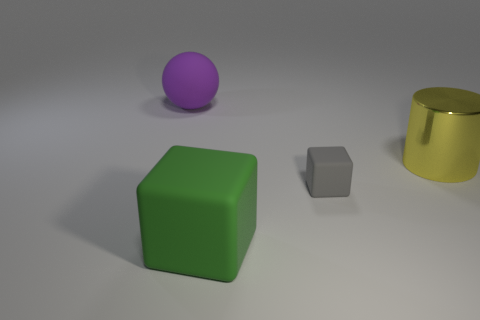Are there fewer gray matte blocks on the right side of the big yellow cylinder than blue rubber blocks?
Make the answer very short. No. Is the material of the large purple sphere the same as the green block?
Provide a succinct answer. Yes. What is the size of the other object that is the same shape as the big green thing?
Provide a short and direct response. Small. What number of things are either matte things behind the cylinder or large matte objects behind the large metal object?
Ensure brevity in your answer.  1. Are there fewer large red rubber things than green matte blocks?
Provide a short and direct response. Yes. Is the size of the purple matte object the same as the rubber cube in front of the small thing?
Offer a terse response. Yes. How many matte things are yellow things or tiny green objects?
Your answer should be very brief. 0. Is the number of small gray matte cubes greater than the number of cubes?
Your answer should be very brief. No. What is the shape of the big matte object that is in front of the object left of the big matte cube?
Give a very brief answer. Cube. There is a block that is behind the big matte thing on the right side of the big purple rubber object; are there any cubes to the left of it?
Your answer should be very brief. Yes. 